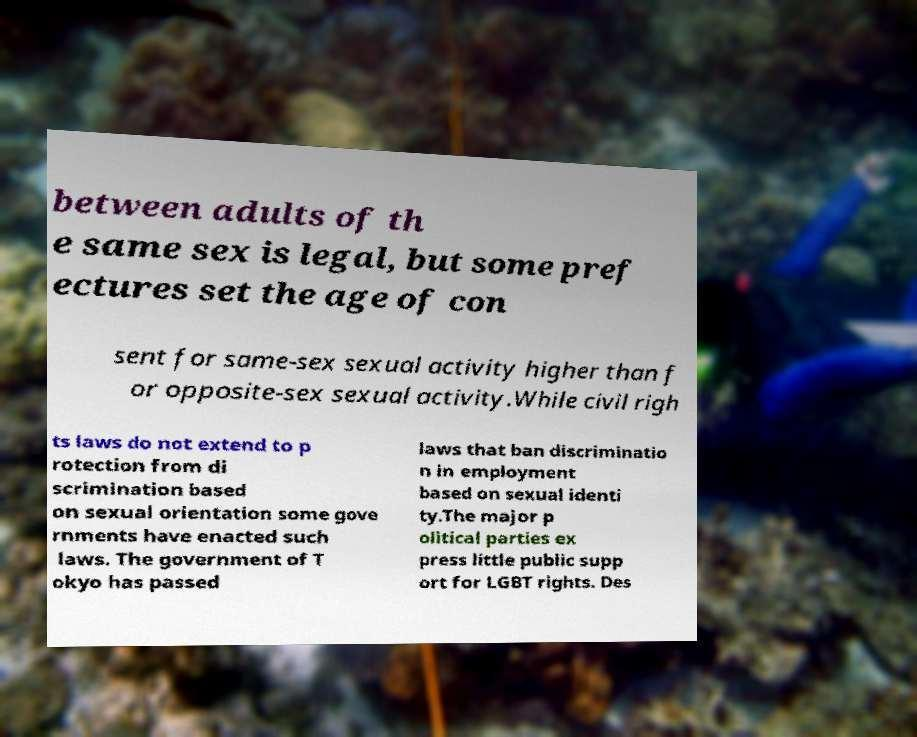Could you assist in decoding the text presented in this image and type it out clearly? between adults of th e same sex is legal, but some pref ectures set the age of con sent for same-sex sexual activity higher than f or opposite-sex sexual activity.While civil righ ts laws do not extend to p rotection from di scrimination based on sexual orientation some gove rnments have enacted such laws. The government of T okyo has passed laws that ban discriminatio n in employment based on sexual identi ty.The major p olitical parties ex press little public supp ort for LGBT rights. Des 